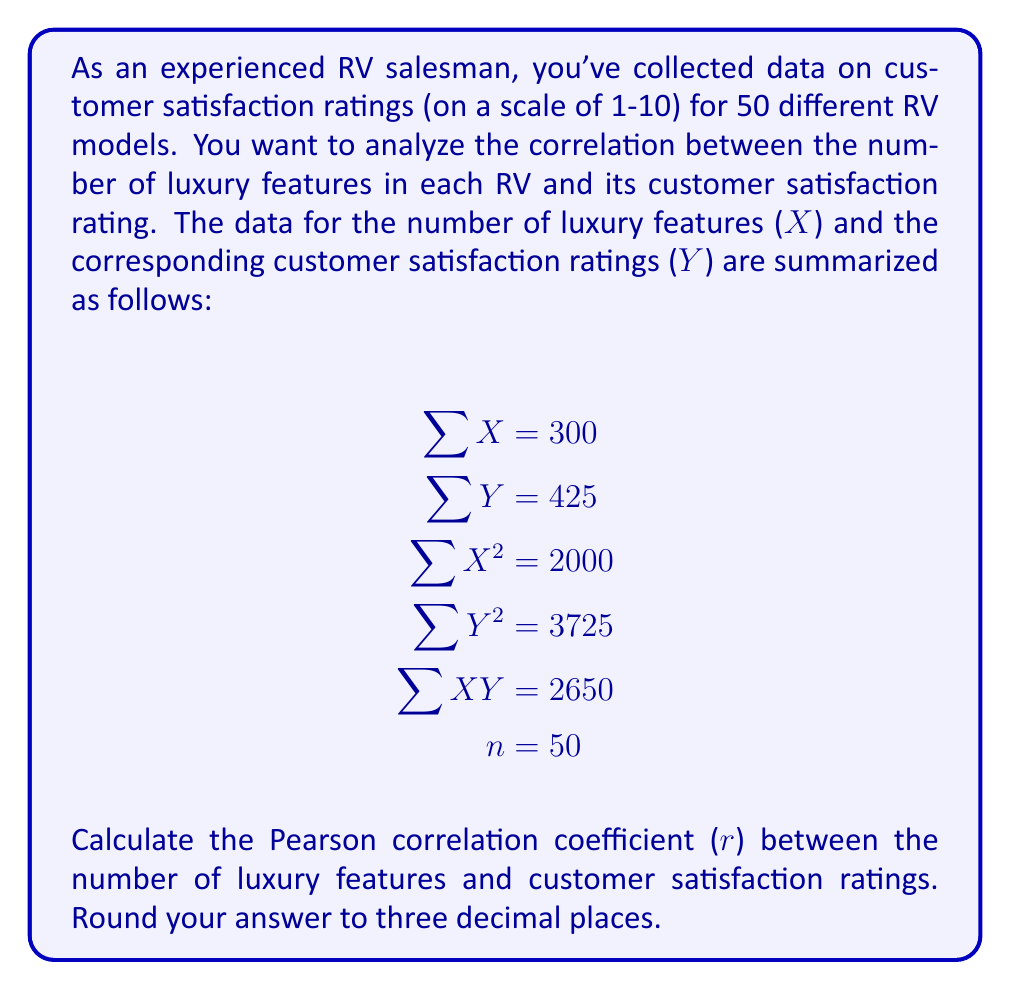Can you solve this math problem? To calculate the Pearson correlation coefficient (r), we'll use the formula:

$$ r = \frac{n\sum XY - \sum X \sum Y}{\sqrt{[n\sum X^2 - (\sum X)^2][n\sum Y^2 - (\sum Y)^2]}} $$

Let's substitute the given values and solve step by step:

1) First, calculate $n\sum XY$:
   $50 \times 2650 = 132500$

2) Calculate $\sum X \sum Y$:
   $300 \times 425 = 127500$

3) Calculate the numerator:
   $132500 - 127500 = 5000$

4) For the denominator, first calculate $n\sum X^2$ and $(\sum X)^2$:
   $n\sum X^2 = 50 \times 2000 = 100000$
   $(\sum X)^2 = 300^2 = 90000$

5) Calculate $n\sum Y^2$ and $(\sum Y)^2$:
   $n\sum Y^2 = 50 \times 3725 = 186250$
   $(\sum Y)^2 = 425^2 = 180625$

6) Complete the denominator calculation:
   $\sqrt{(100000 - 90000)(186250 - 180625)}$
   $= \sqrt{(10000)(5625)}$
   $= \sqrt{56250000}$
   $= 7500$

7) Finally, divide the numerator by the denominator:
   $r = \frac{5000}{7500} = 0.6667$

8) Rounding to three decimal places:
   $r \approx 0.667$
Answer: $r \approx 0.667$ 